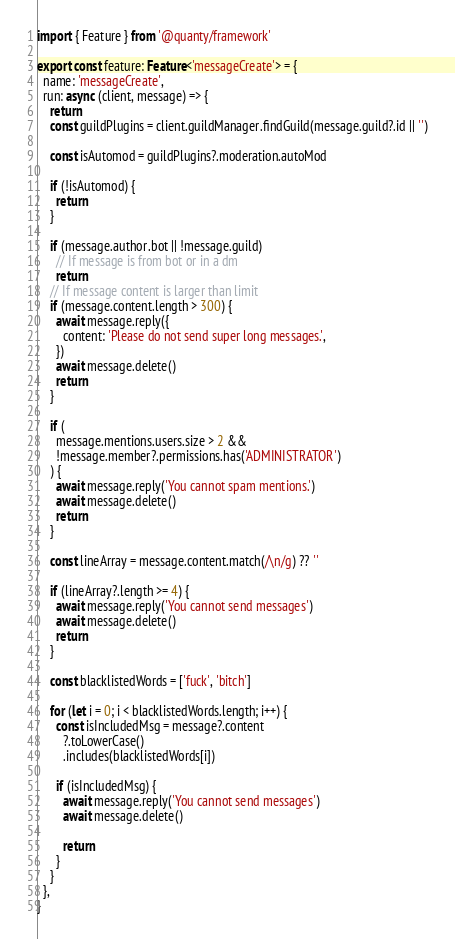Convert code to text. <code><loc_0><loc_0><loc_500><loc_500><_TypeScript_>import { Feature } from '@quanty/framework'

export const feature: Feature<'messageCreate'> = {
  name: 'messageCreate',
  run: async (client, message) => {
    return
    const guildPlugins = client.guildManager.findGuild(message.guild?.id || '')

    const isAutomod = guildPlugins?.moderation.autoMod

    if (!isAutomod) {
      return
    }

    if (message.author.bot || !message.guild)
      // If message is from bot or in a dm
      return
    // If message content is larger than limit
    if (message.content.length > 300) {
      await message.reply({
        content: 'Please do not send super long messages.',
      })
      await message.delete()
      return
    }

    if (
      message.mentions.users.size > 2 &&
      !message.member?.permissions.has('ADMINISTRATOR')
    ) {
      await message.reply('You cannot spam mentions.')
      await message.delete()
      return
    }

    const lineArray = message.content.match(/\n/g) ?? ''

    if (lineArray?.length >= 4) {
      await message.reply('You cannot send messages')
      await message.delete()
      return
    }

    const blacklistedWords = ['fuck', 'bitch']

    for (let i = 0; i < blacklistedWords.length; i++) {
      const isIncludedMsg = message?.content
        ?.toLowerCase()
        .includes(blacklistedWords[i])

      if (isIncludedMsg) {
        await message.reply('You cannot send messages')
        await message.delete()

        return
      }
    }
  },
}
</code> 